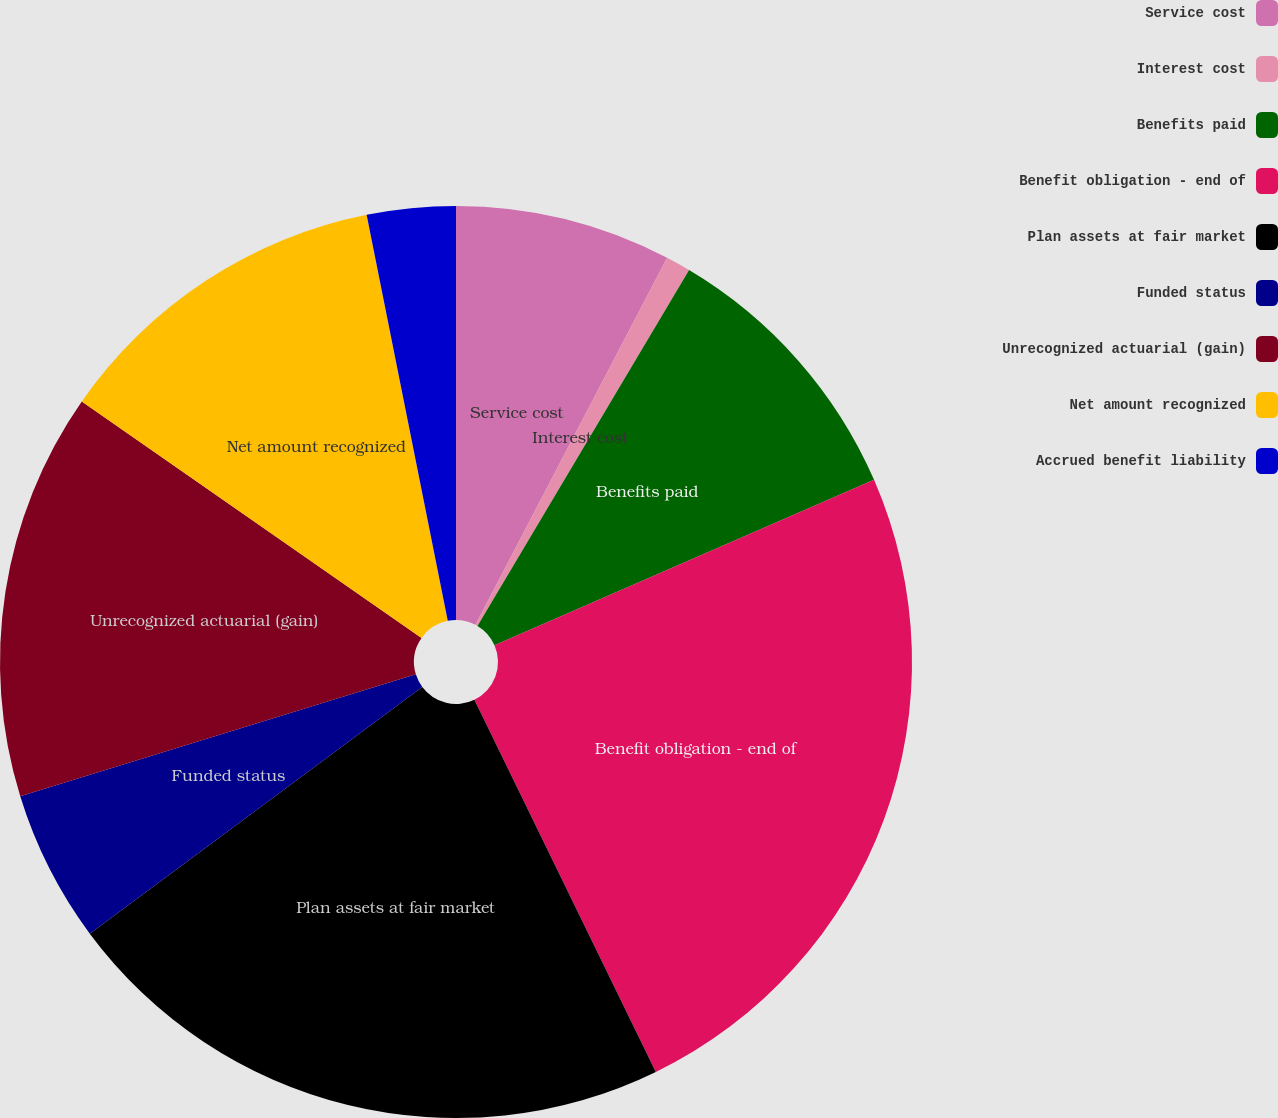Convert chart to OTSL. <chart><loc_0><loc_0><loc_500><loc_500><pie_chart><fcel>Service cost<fcel>Interest cost<fcel>Benefits paid<fcel>Benefit obligation - end of<fcel>Plan assets at fair market<fcel>Funded status<fcel>Unrecognized actuarial (gain)<fcel>Net amount recognized<fcel>Accrued benefit liability<nl><fcel>7.66%<fcel>0.88%<fcel>9.92%<fcel>24.32%<fcel>22.06%<fcel>5.4%<fcel>14.44%<fcel>12.18%<fcel>3.14%<nl></chart> 